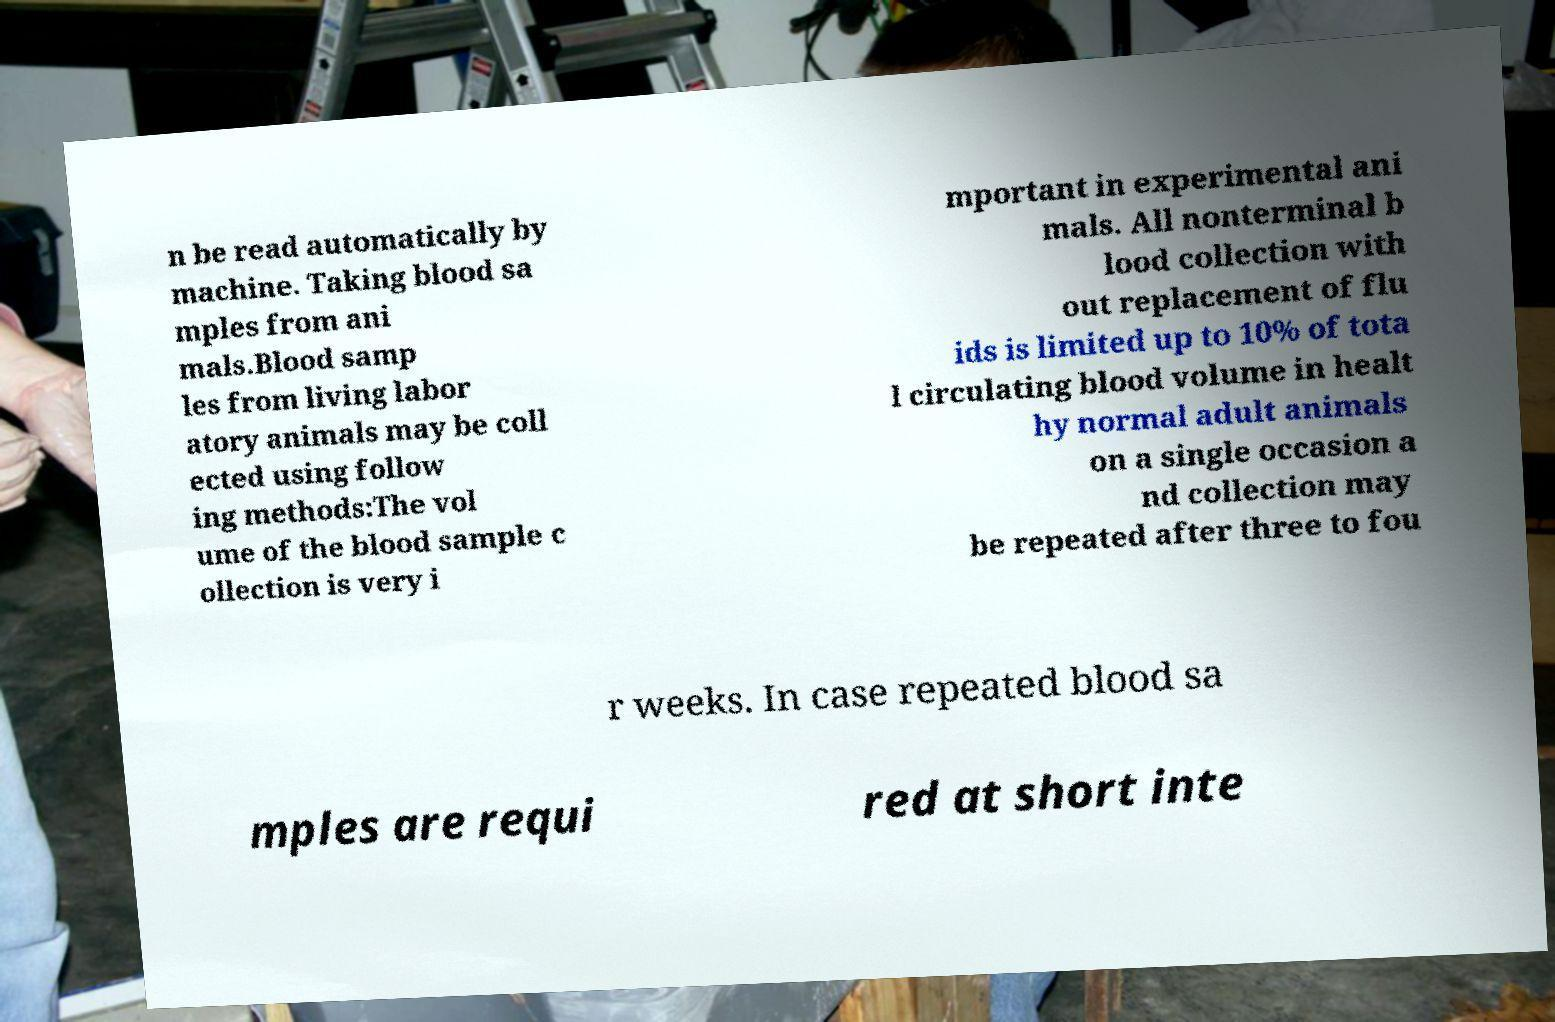Could you assist in decoding the text presented in this image and type it out clearly? n be read automatically by machine. Taking blood sa mples from ani mals.Blood samp les from living labor atory animals may be coll ected using follow ing methods:The vol ume of the blood sample c ollection is very i mportant in experimental ani mals. All nonterminal b lood collection with out replacement of flu ids is limited up to 10% of tota l circulating blood volume in healt hy normal adult animals on a single occasion a nd collection may be repeated after three to fou r weeks. In case repeated blood sa mples are requi red at short inte 